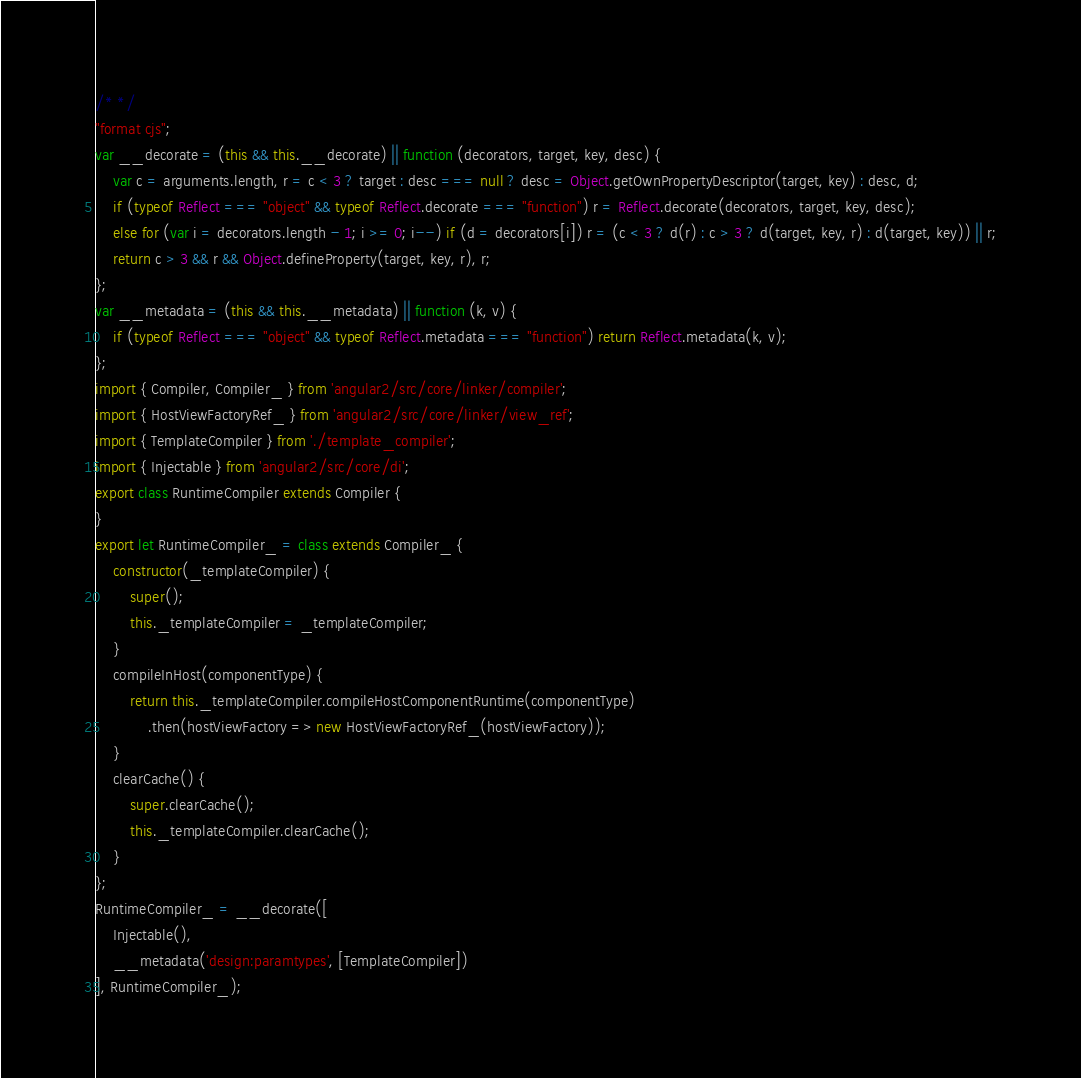Convert code to text. <code><loc_0><loc_0><loc_500><loc_500><_JavaScript_>/* */ 
"format cjs";
var __decorate = (this && this.__decorate) || function (decorators, target, key, desc) {
    var c = arguments.length, r = c < 3 ? target : desc === null ? desc = Object.getOwnPropertyDescriptor(target, key) : desc, d;
    if (typeof Reflect === "object" && typeof Reflect.decorate === "function") r = Reflect.decorate(decorators, target, key, desc);
    else for (var i = decorators.length - 1; i >= 0; i--) if (d = decorators[i]) r = (c < 3 ? d(r) : c > 3 ? d(target, key, r) : d(target, key)) || r;
    return c > 3 && r && Object.defineProperty(target, key, r), r;
};
var __metadata = (this && this.__metadata) || function (k, v) {
    if (typeof Reflect === "object" && typeof Reflect.metadata === "function") return Reflect.metadata(k, v);
};
import { Compiler, Compiler_ } from 'angular2/src/core/linker/compiler';
import { HostViewFactoryRef_ } from 'angular2/src/core/linker/view_ref';
import { TemplateCompiler } from './template_compiler';
import { Injectable } from 'angular2/src/core/di';
export class RuntimeCompiler extends Compiler {
}
export let RuntimeCompiler_ = class extends Compiler_ {
    constructor(_templateCompiler) {
        super();
        this._templateCompiler = _templateCompiler;
    }
    compileInHost(componentType) {
        return this._templateCompiler.compileHostComponentRuntime(componentType)
            .then(hostViewFactory => new HostViewFactoryRef_(hostViewFactory));
    }
    clearCache() {
        super.clearCache();
        this._templateCompiler.clearCache();
    }
};
RuntimeCompiler_ = __decorate([
    Injectable(), 
    __metadata('design:paramtypes', [TemplateCompiler])
], RuntimeCompiler_);</code> 